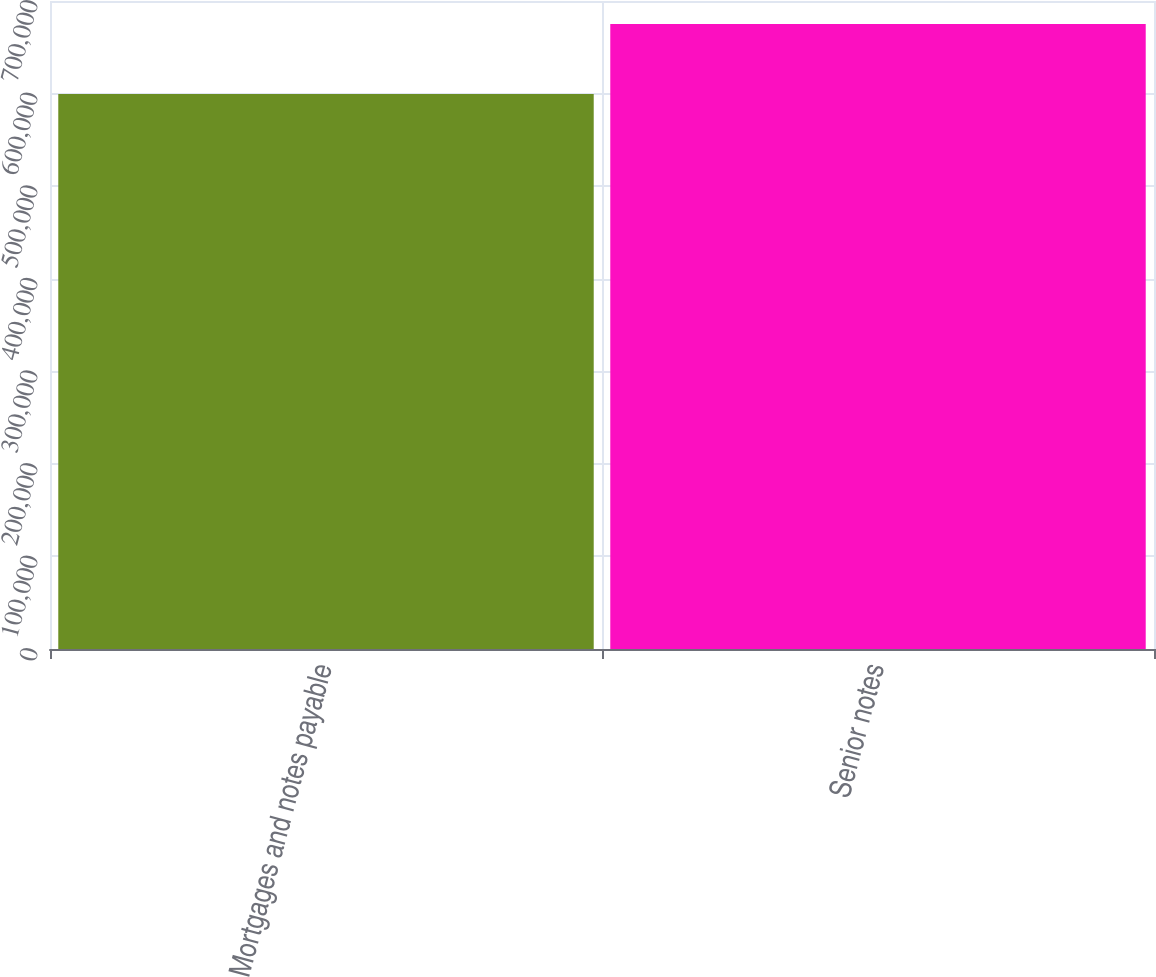<chart> <loc_0><loc_0><loc_500><loc_500><bar_chart><fcel>Mortgages and notes payable<fcel>Senior notes<nl><fcel>599667<fcel>675278<nl></chart> 